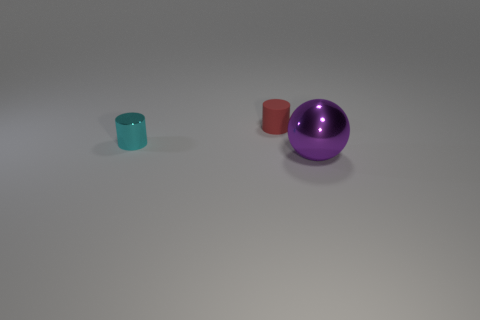Add 1 small red metallic cylinders. How many objects exist? 4 Subtract all balls. How many objects are left? 2 Subtract all tiny cyan things. Subtract all big cyan matte spheres. How many objects are left? 2 Add 3 tiny cyan things. How many tiny cyan things are left? 4 Add 3 cyan cylinders. How many cyan cylinders exist? 4 Subtract 0 gray blocks. How many objects are left? 3 